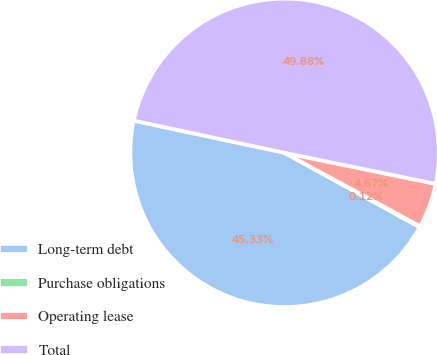<chart> <loc_0><loc_0><loc_500><loc_500><pie_chart><fcel>Long-term debt<fcel>Purchase obligations<fcel>Operating lease<fcel>Total<nl><fcel>45.33%<fcel>0.12%<fcel>4.67%<fcel>49.88%<nl></chart> 